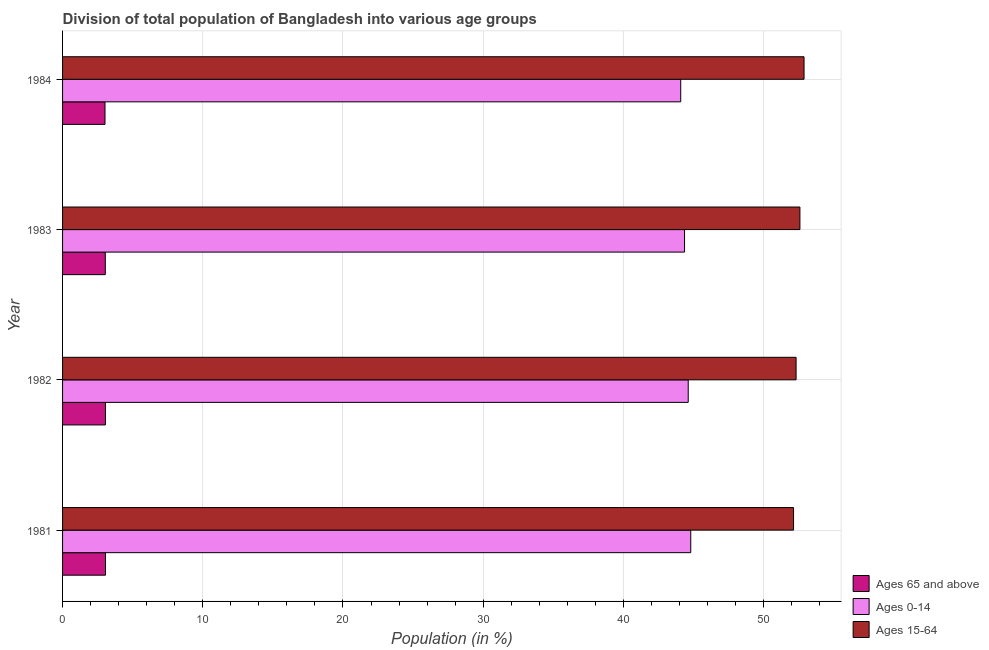How many different coloured bars are there?
Provide a short and direct response. 3. How many groups of bars are there?
Your answer should be very brief. 4. How many bars are there on the 3rd tick from the bottom?
Your answer should be compact. 3. What is the label of the 3rd group of bars from the top?
Offer a very short reply. 1982. What is the percentage of population within the age-group 15-64 in 1984?
Your response must be concise. 52.88. Across all years, what is the maximum percentage of population within the age-group 15-64?
Offer a very short reply. 52.88. Across all years, what is the minimum percentage of population within the age-group of 65 and above?
Your answer should be compact. 3.03. In which year was the percentage of population within the age-group of 65 and above maximum?
Give a very brief answer. 1981. What is the total percentage of population within the age-group 15-64 in the graph?
Provide a succinct answer. 209.93. What is the difference between the percentage of population within the age-group 0-14 in 1982 and that in 1984?
Offer a very short reply. 0.53. What is the difference between the percentage of population within the age-group of 65 and above in 1984 and the percentage of population within the age-group 0-14 in 1981?
Your answer should be very brief. -41.78. What is the average percentage of population within the age-group 15-64 per year?
Make the answer very short. 52.48. In the year 1983, what is the difference between the percentage of population within the age-group 0-14 and percentage of population within the age-group of 65 and above?
Offer a very short reply. 41.31. Is the percentage of population within the age-group of 65 and above in 1981 less than that in 1984?
Provide a succinct answer. No. What is the difference between the highest and the lowest percentage of population within the age-group 0-14?
Your answer should be compact. 0.71. In how many years, is the percentage of population within the age-group 0-14 greater than the average percentage of population within the age-group 0-14 taken over all years?
Offer a very short reply. 2. What does the 1st bar from the top in 1984 represents?
Your response must be concise. Ages 15-64. What does the 2nd bar from the bottom in 1982 represents?
Ensure brevity in your answer.  Ages 0-14. Are the values on the major ticks of X-axis written in scientific E-notation?
Ensure brevity in your answer.  No. Does the graph contain any zero values?
Give a very brief answer. No. How many legend labels are there?
Give a very brief answer. 3. How are the legend labels stacked?
Make the answer very short. Vertical. What is the title of the graph?
Provide a succinct answer. Division of total population of Bangladesh into various age groups
. What is the label or title of the X-axis?
Your answer should be very brief. Population (in %). What is the label or title of the Y-axis?
Keep it short and to the point. Year. What is the Population (in %) in Ages 65 and above in 1981?
Make the answer very short. 3.06. What is the Population (in %) of Ages 0-14 in 1981?
Offer a very short reply. 44.8. What is the Population (in %) in Ages 15-64 in 1981?
Your answer should be very brief. 52.14. What is the Population (in %) in Ages 65 and above in 1982?
Make the answer very short. 3.06. What is the Population (in %) of Ages 0-14 in 1982?
Offer a very short reply. 44.62. What is the Population (in %) of Ages 15-64 in 1982?
Ensure brevity in your answer.  52.32. What is the Population (in %) in Ages 65 and above in 1983?
Give a very brief answer. 3.05. What is the Population (in %) of Ages 0-14 in 1983?
Your answer should be very brief. 44.36. What is the Population (in %) in Ages 15-64 in 1983?
Provide a succinct answer. 52.59. What is the Population (in %) of Ages 65 and above in 1984?
Your response must be concise. 3.03. What is the Population (in %) of Ages 0-14 in 1984?
Your answer should be compact. 44.09. What is the Population (in %) in Ages 15-64 in 1984?
Offer a terse response. 52.88. Across all years, what is the maximum Population (in %) in Ages 65 and above?
Keep it short and to the point. 3.06. Across all years, what is the maximum Population (in %) in Ages 0-14?
Give a very brief answer. 44.8. Across all years, what is the maximum Population (in %) of Ages 15-64?
Your response must be concise. 52.88. Across all years, what is the minimum Population (in %) in Ages 65 and above?
Offer a terse response. 3.03. Across all years, what is the minimum Population (in %) in Ages 0-14?
Your answer should be very brief. 44.09. Across all years, what is the minimum Population (in %) in Ages 15-64?
Make the answer very short. 52.14. What is the total Population (in %) of Ages 65 and above in the graph?
Ensure brevity in your answer.  12.19. What is the total Population (in %) in Ages 0-14 in the graph?
Your answer should be very brief. 177.88. What is the total Population (in %) in Ages 15-64 in the graph?
Provide a succinct answer. 209.93. What is the difference between the Population (in %) of Ages 65 and above in 1981 and that in 1982?
Your answer should be very brief. 0. What is the difference between the Population (in %) in Ages 0-14 in 1981 and that in 1982?
Make the answer very short. 0.18. What is the difference between the Population (in %) in Ages 15-64 in 1981 and that in 1982?
Give a very brief answer. -0.18. What is the difference between the Population (in %) of Ages 65 and above in 1981 and that in 1983?
Ensure brevity in your answer.  0.01. What is the difference between the Population (in %) of Ages 0-14 in 1981 and that in 1983?
Give a very brief answer. 0.44. What is the difference between the Population (in %) in Ages 15-64 in 1981 and that in 1983?
Give a very brief answer. -0.45. What is the difference between the Population (in %) in Ages 65 and above in 1981 and that in 1984?
Your response must be concise. 0.03. What is the difference between the Population (in %) in Ages 0-14 in 1981 and that in 1984?
Provide a succinct answer. 0.71. What is the difference between the Population (in %) of Ages 15-64 in 1981 and that in 1984?
Make the answer very short. -0.75. What is the difference between the Population (in %) of Ages 65 and above in 1982 and that in 1983?
Offer a terse response. 0.01. What is the difference between the Population (in %) of Ages 0-14 in 1982 and that in 1983?
Give a very brief answer. 0.26. What is the difference between the Population (in %) in Ages 15-64 in 1982 and that in 1983?
Keep it short and to the point. -0.27. What is the difference between the Population (in %) of Ages 65 and above in 1982 and that in 1984?
Offer a terse response. 0.03. What is the difference between the Population (in %) in Ages 0-14 in 1982 and that in 1984?
Keep it short and to the point. 0.53. What is the difference between the Population (in %) of Ages 15-64 in 1982 and that in 1984?
Your answer should be very brief. -0.57. What is the difference between the Population (in %) of Ages 65 and above in 1983 and that in 1984?
Keep it short and to the point. 0.02. What is the difference between the Population (in %) of Ages 0-14 in 1983 and that in 1984?
Give a very brief answer. 0.27. What is the difference between the Population (in %) in Ages 15-64 in 1983 and that in 1984?
Give a very brief answer. -0.29. What is the difference between the Population (in %) of Ages 65 and above in 1981 and the Population (in %) of Ages 0-14 in 1982?
Your answer should be very brief. -41.56. What is the difference between the Population (in %) in Ages 65 and above in 1981 and the Population (in %) in Ages 15-64 in 1982?
Your answer should be very brief. -49.26. What is the difference between the Population (in %) of Ages 0-14 in 1981 and the Population (in %) of Ages 15-64 in 1982?
Provide a succinct answer. -7.51. What is the difference between the Population (in %) of Ages 65 and above in 1981 and the Population (in %) of Ages 0-14 in 1983?
Ensure brevity in your answer.  -41.3. What is the difference between the Population (in %) in Ages 65 and above in 1981 and the Population (in %) in Ages 15-64 in 1983?
Make the answer very short. -49.53. What is the difference between the Population (in %) in Ages 0-14 in 1981 and the Population (in %) in Ages 15-64 in 1983?
Ensure brevity in your answer.  -7.79. What is the difference between the Population (in %) in Ages 65 and above in 1981 and the Population (in %) in Ages 0-14 in 1984?
Offer a very short reply. -41.03. What is the difference between the Population (in %) in Ages 65 and above in 1981 and the Population (in %) in Ages 15-64 in 1984?
Keep it short and to the point. -49.82. What is the difference between the Population (in %) of Ages 0-14 in 1981 and the Population (in %) of Ages 15-64 in 1984?
Make the answer very short. -8.08. What is the difference between the Population (in %) in Ages 65 and above in 1982 and the Population (in %) in Ages 0-14 in 1983?
Make the answer very short. -41.3. What is the difference between the Population (in %) in Ages 65 and above in 1982 and the Population (in %) in Ages 15-64 in 1983?
Ensure brevity in your answer.  -49.53. What is the difference between the Population (in %) of Ages 0-14 in 1982 and the Population (in %) of Ages 15-64 in 1983?
Your answer should be compact. -7.97. What is the difference between the Population (in %) of Ages 65 and above in 1982 and the Population (in %) of Ages 0-14 in 1984?
Your answer should be compact. -41.03. What is the difference between the Population (in %) of Ages 65 and above in 1982 and the Population (in %) of Ages 15-64 in 1984?
Your response must be concise. -49.83. What is the difference between the Population (in %) in Ages 0-14 in 1982 and the Population (in %) in Ages 15-64 in 1984?
Your answer should be compact. -8.26. What is the difference between the Population (in %) of Ages 65 and above in 1983 and the Population (in %) of Ages 0-14 in 1984?
Offer a terse response. -41.04. What is the difference between the Population (in %) of Ages 65 and above in 1983 and the Population (in %) of Ages 15-64 in 1984?
Your answer should be very brief. -49.84. What is the difference between the Population (in %) in Ages 0-14 in 1983 and the Population (in %) in Ages 15-64 in 1984?
Your answer should be very brief. -8.52. What is the average Population (in %) of Ages 65 and above per year?
Give a very brief answer. 3.05. What is the average Population (in %) in Ages 0-14 per year?
Your answer should be compact. 44.47. What is the average Population (in %) of Ages 15-64 per year?
Offer a very short reply. 52.48. In the year 1981, what is the difference between the Population (in %) in Ages 65 and above and Population (in %) in Ages 0-14?
Your response must be concise. -41.74. In the year 1981, what is the difference between the Population (in %) in Ages 65 and above and Population (in %) in Ages 15-64?
Make the answer very short. -49.08. In the year 1981, what is the difference between the Population (in %) in Ages 0-14 and Population (in %) in Ages 15-64?
Offer a terse response. -7.33. In the year 1982, what is the difference between the Population (in %) in Ages 65 and above and Population (in %) in Ages 0-14?
Make the answer very short. -41.56. In the year 1982, what is the difference between the Population (in %) in Ages 65 and above and Population (in %) in Ages 15-64?
Keep it short and to the point. -49.26. In the year 1982, what is the difference between the Population (in %) in Ages 0-14 and Population (in %) in Ages 15-64?
Ensure brevity in your answer.  -7.69. In the year 1983, what is the difference between the Population (in %) of Ages 65 and above and Population (in %) of Ages 0-14?
Make the answer very short. -41.31. In the year 1983, what is the difference between the Population (in %) of Ages 65 and above and Population (in %) of Ages 15-64?
Ensure brevity in your answer.  -49.54. In the year 1983, what is the difference between the Population (in %) of Ages 0-14 and Population (in %) of Ages 15-64?
Give a very brief answer. -8.23. In the year 1984, what is the difference between the Population (in %) of Ages 65 and above and Population (in %) of Ages 0-14?
Your answer should be compact. -41.06. In the year 1984, what is the difference between the Population (in %) in Ages 65 and above and Population (in %) in Ages 15-64?
Keep it short and to the point. -49.86. In the year 1984, what is the difference between the Population (in %) of Ages 0-14 and Population (in %) of Ages 15-64?
Your response must be concise. -8.8. What is the ratio of the Population (in %) in Ages 0-14 in 1981 to that in 1982?
Ensure brevity in your answer.  1. What is the ratio of the Population (in %) in Ages 15-64 in 1981 to that in 1982?
Provide a short and direct response. 1. What is the ratio of the Population (in %) in Ages 65 and above in 1981 to that in 1983?
Offer a terse response. 1. What is the ratio of the Population (in %) in Ages 0-14 in 1981 to that in 1983?
Offer a very short reply. 1.01. What is the ratio of the Population (in %) in Ages 65 and above in 1981 to that in 1984?
Your answer should be very brief. 1.01. What is the ratio of the Population (in %) of Ages 0-14 in 1981 to that in 1984?
Offer a terse response. 1.02. What is the ratio of the Population (in %) of Ages 15-64 in 1981 to that in 1984?
Ensure brevity in your answer.  0.99. What is the ratio of the Population (in %) of Ages 65 and above in 1982 to that in 1983?
Your answer should be very brief. 1. What is the ratio of the Population (in %) in Ages 0-14 in 1982 to that in 1983?
Your answer should be very brief. 1.01. What is the ratio of the Population (in %) of Ages 15-64 in 1982 to that in 1983?
Offer a very short reply. 0.99. What is the ratio of the Population (in %) in Ages 65 and above in 1982 to that in 1984?
Give a very brief answer. 1.01. What is the ratio of the Population (in %) in Ages 0-14 in 1982 to that in 1984?
Offer a very short reply. 1.01. What is the ratio of the Population (in %) in Ages 15-64 in 1982 to that in 1984?
Ensure brevity in your answer.  0.99. What is the ratio of the Population (in %) of Ages 65 and above in 1983 to that in 1984?
Provide a short and direct response. 1.01. What is the ratio of the Population (in %) in Ages 0-14 in 1983 to that in 1984?
Your response must be concise. 1.01. What is the difference between the highest and the second highest Population (in %) of Ages 65 and above?
Ensure brevity in your answer.  0. What is the difference between the highest and the second highest Population (in %) in Ages 0-14?
Give a very brief answer. 0.18. What is the difference between the highest and the second highest Population (in %) of Ages 15-64?
Your answer should be very brief. 0.29. What is the difference between the highest and the lowest Population (in %) of Ages 65 and above?
Give a very brief answer. 0.03. What is the difference between the highest and the lowest Population (in %) in Ages 0-14?
Ensure brevity in your answer.  0.71. What is the difference between the highest and the lowest Population (in %) in Ages 15-64?
Give a very brief answer. 0.75. 